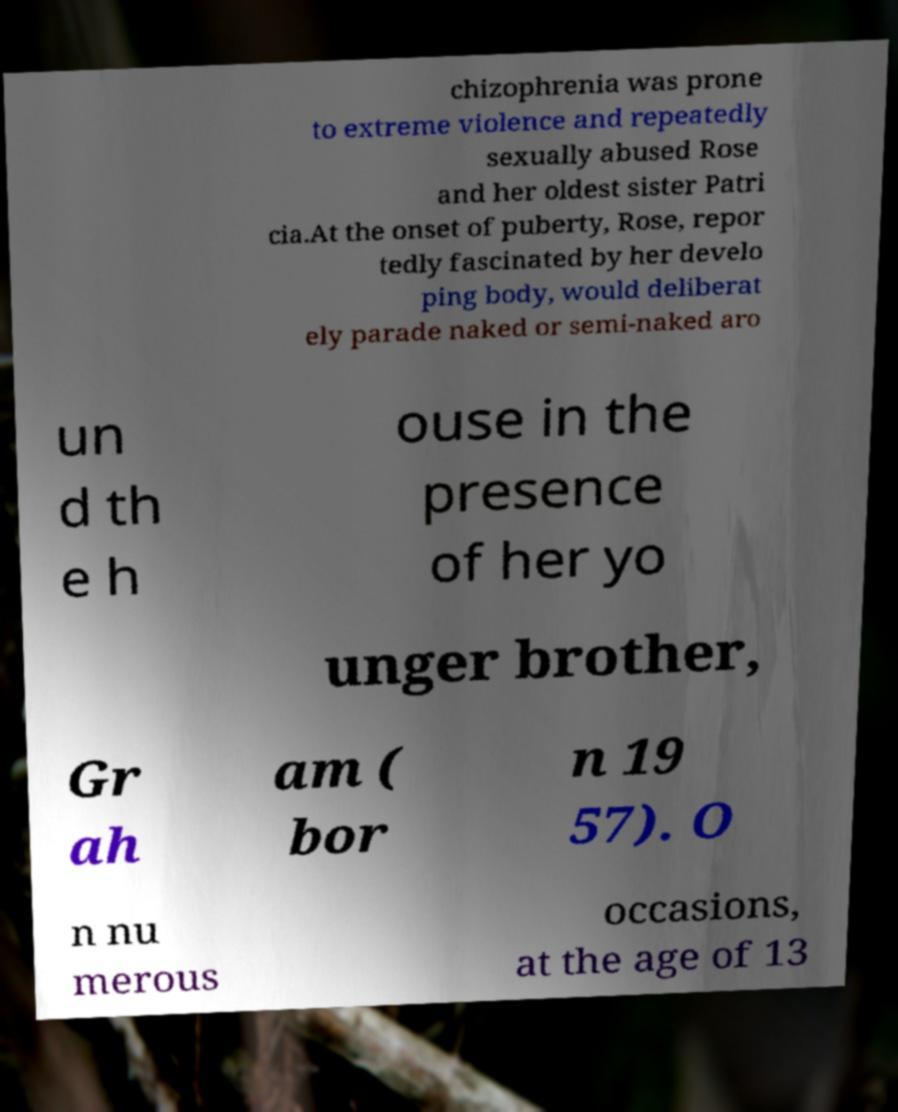Could you extract and type out the text from this image? chizophrenia was prone to extreme violence and repeatedly sexually abused Rose and her oldest sister Patri cia.At the onset of puberty, Rose, repor tedly fascinated by her develo ping body, would deliberat ely parade naked or semi-naked aro un d th e h ouse in the presence of her yo unger brother, Gr ah am ( bor n 19 57). O n nu merous occasions, at the age of 13 